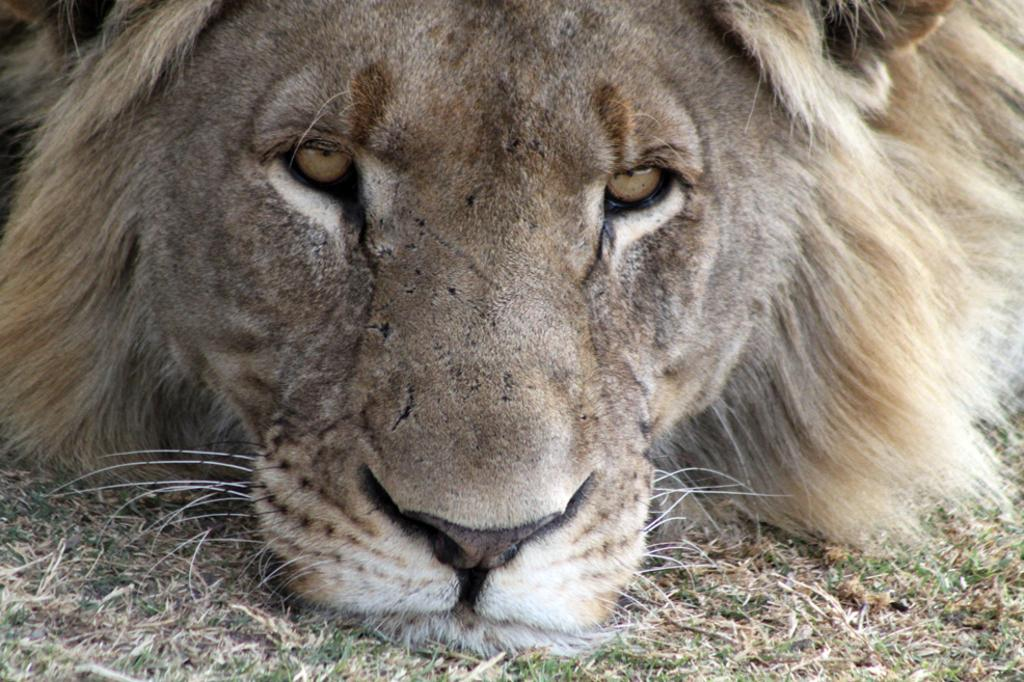What animal is present in the image? There is a lion in the image. What is the lion's position in the image? The lion is lying on the grassland. What type of mountain can be seen in the background of the image? There is no mountain present in the image; it features a lion lying on the grassland. What is the texture of the lion's fur in the image? The image does not provide enough detail to determine the texture of the lion's fur. 